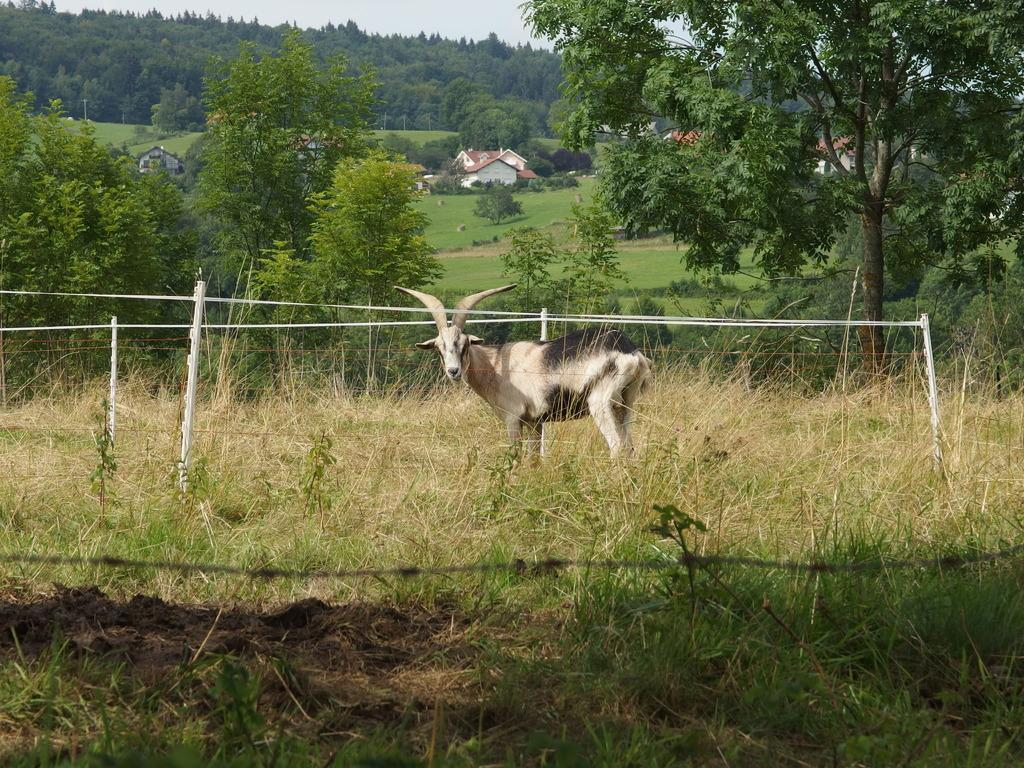What type of animal is on the ground in the image? The specific type of animal cannot be determined from the image. What can be seen in the image besides the animal? There is a group of poles and buildings in the background, as well as groups of trees and the sky visible in the background. Can you describe the poles in the image? There is a group of poles in the image, but their specific purpose or appearance cannot be determined from the provided facts. What is visible in the background of the image? In the background of the image, there are buildings, groups of trees, and the sky. Where is the basin located in the image? There is no basin present in the image. What type of boundary is visible in the image? There is no boundary visible in the image. 